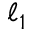<formula> <loc_0><loc_0><loc_500><loc_500>\ell _ { 1 }</formula> 